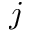Convert formula to latex. <formula><loc_0><loc_0><loc_500><loc_500>j</formula> 